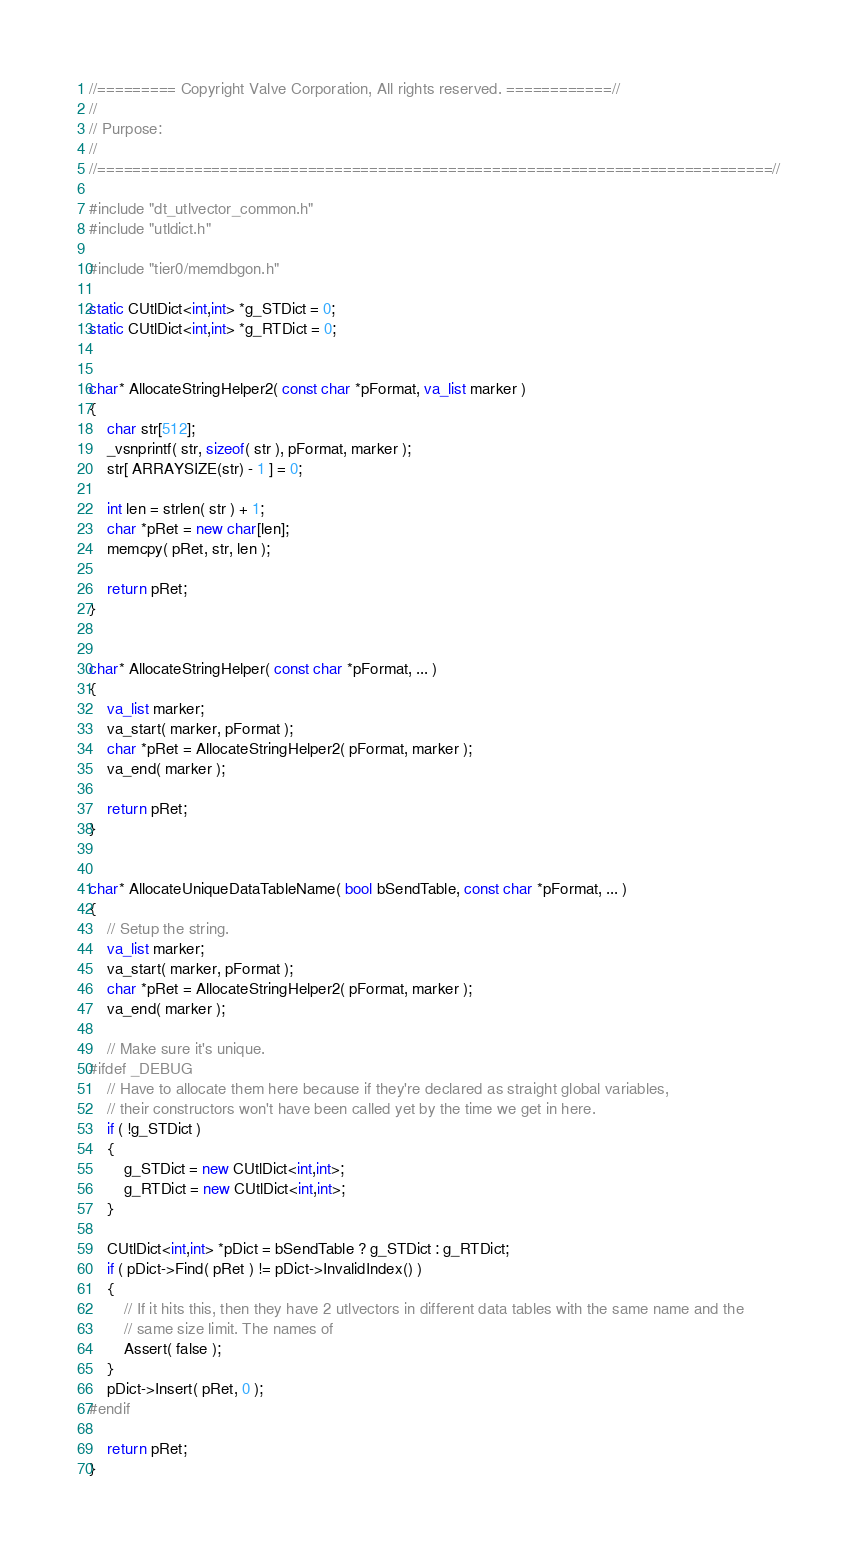Convert code to text. <code><loc_0><loc_0><loc_500><loc_500><_C++_>//========= Copyright Valve Corporation, All rights reserved. ============//
//
// Purpose: 
//
//=============================================================================//

#include "dt_utlvector_common.h"
#include "utldict.h"

#include "tier0/memdbgon.h"

static CUtlDict<int,int> *g_STDict = 0;
static CUtlDict<int,int> *g_RTDict = 0;


char* AllocateStringHelper2( const char *pFormat, va_list marker )
{
	char str[512];
	_vsnprintf( str, sizeof( str ), pFormat, marker );
	str[ ARRAYSIZE(str) - 1 ] = 0;
	
	int len = strlen( str ) + 1;
	char *pRet = new char[len];
	memcpy( pRet, str, len );

	return pRet;
}


char* AllocateStringHelper( const char *pFormat, ... )
{
	va_list marker;
	va_start( marker, pFormat );
	char *pRet = AllocateStringHelper2( pFormat, marker );
	va_end( marker );

	return pRet;
}


char* AllocateUniqueDataTableName( bool bSendTable, const char *pFormat, ... )
{
	// Setup the string.
	va_list marker;
	va_start( marker, pFormat );
	char *pRet = AllocateStringHelper2( pFormat, marker );
	va_end( marker );

	// Make sure it's unique.
#ifdef _DEBUG
	// Have to allocate them here because if they're declared as straight global variables,
	// their constructors won't have been called yet by the time we get in here.
	if ( !g_STDict )
	{
		g_STDict = new CUtlDict<int,int>;
		g_RTDict = new CUtlDict<int,int>;
	}

	CUtlDict<int,int> *pDict = bSendTable ? g_STDict : g_RTDict;
	if ( pDict->Find( pRet ) != pDict->InvalidIndex() )
	{
		// If it hits this, then they have 2 utlvectors in different data tables with the same name and the
		// same size limit. The names of 
		Assert( false );
	}
	pDict->Insert( pRet, 0 );
#endif

	return pRet;
}
</code> 